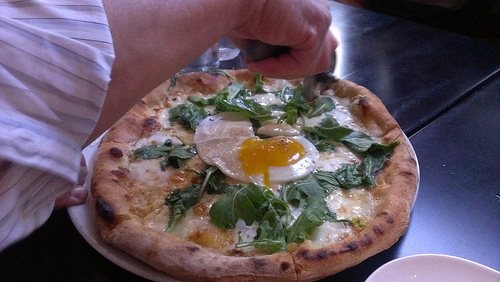Imagine a scenario where this pizza goes on an adventure. Where would it go and what would it encounter? In our whimsical pizza's adventure, it embarks on a journey across a land made entirely of food! First, it navigates through a forest of towering broccoli trees, where it befriends a friendly tomato who guides it to the River of Sauce. They sail downstream on a cheese raft, passing by the bustling Bread Village, where the aroma of freshly baked bread wafts through the air. Suddenly, they face the treacherous Spicy Pepper Canyon, where the pizza's runny yolk egg reveals a hidden power to cool down the heat with a sprinkling of fresh herbs. Finally, after many delicious encounters, they arrive at the majestic Mozzarella Mountain, where the pizza discovers a legend about the perfect recipe. It's a fun-filled adventure that celebrates the joy of food and friendship! 